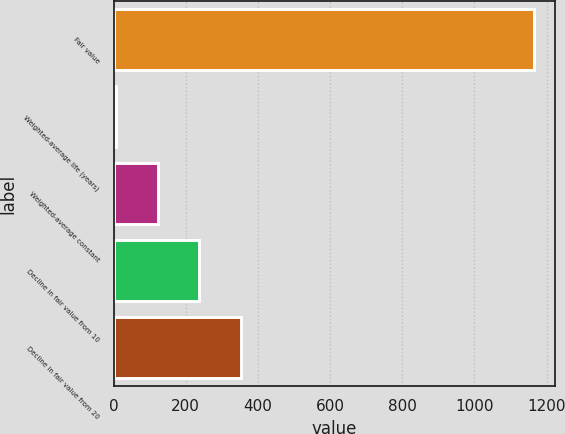Convert chart to OTSL. <chart><loc_0><loc_0><loc_500><loc_500><bar_chart><fcel>Fair value<fcel>Weighted-average life (years)<fcel>Weighted-average constant<fcel>Decline in fair value from 10<fcel>Decline in fair value from 20<nl><fcel>1164<fcel>6.4<fcel>122.16<fcel>237.92<fcel>353.68<nl></chart> 